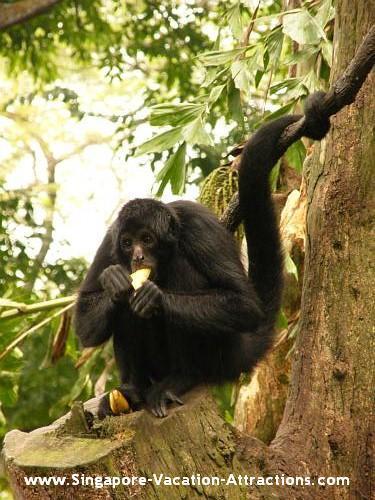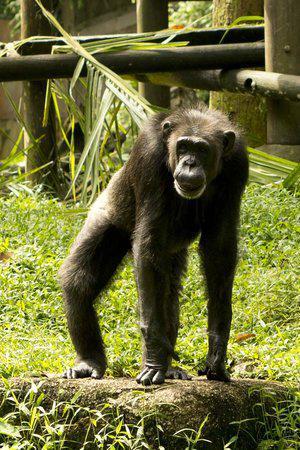The first image is the image on the left, the second image is the image on the right. For the images displayed, is the sentence "a child ape is on its mothers back." factually correct? Answer yes or no. No. The first image is the image on the left, the second image is the image on the right. Evaluate the accuracy of this statement regarding the images: "One of the images shows one monkey riding on the back of another monkey.". Is it true? Answer yes or no. No. 